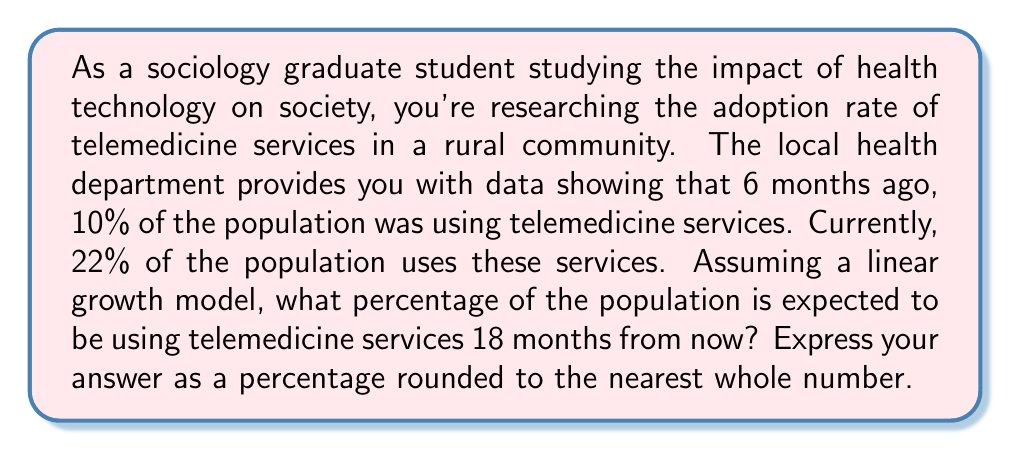Provide a solution to this math problem. Let's approach this step-by-step using a linear function to model the adoption rate:

1) Let's define our variables:
   $x$ = time in months (with $x = 0$ being 6 months ago)
   $y$ = percentage of population using telemedicine services

2) We know two points on this line:
   $(0, 10)$ : 6 months ago, 10% were using the services
   $(6, 22)$ : Now (6 months later), 22% are using the services

3) We can use these points to find the slope $(m)$ of our linear function:

   $$m = \frac{y_2 - y_1}{x_2 - x_1} = \frac{22 - 10}{6 - 0} = \frac{12}{6} = 2$$

4) This means the adoption rate is increasing by 2 percentage points per month.

5) Now we can form our linear equation using the point-slope form:
   $y - y_1 = m(x - x_1)$
   $y - 10 = 2(x - 0)$
   $y = 2x + 10$

6) To find the adoption rate 18 months from now, we need to calculate $y$ when $x = 24$ (6 months ago + 6 months to now + 18 months in the future):

   $y = 2(24) + 10 = 48 + 10 = 58$

Therefore, 58% of the population is expected to be using telemedicine services 18 months from now.
Answer: 58% 